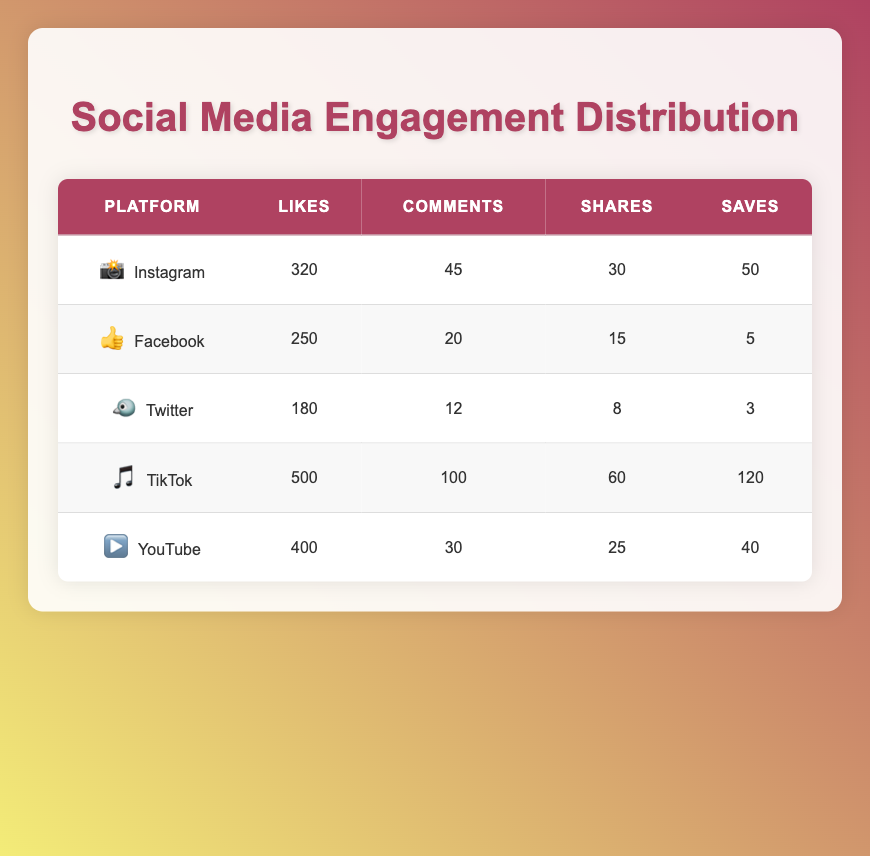What social media platform had the highest number of likes? By looking at the "Likes" column, TikTok has the highest value of 500 likes, which is greater than any other platform's like count.
Answer: TikTok Which platform had the least number of comments? The "Comments" column indicates that Twitter had the least comments, totaling 12, which is lower than any other platform's comments.
Answer: Twitter What is the total number of shares across all platforms? To find the total number of shares, we add the shares from each platform: (30 + 15 + 8 + 60 + 25) = 138 shares in total.
Answer: 138 How many more likes did Instagram receive compared to Facebook? We subtract Facebook's likes (250) from Instagram's likes (320): 320 - 250 = 70. Therefore, Instagram received 70 more likes than Facebook.
Answer: 70 Is it true that YouTube had more saves than Facebook? By comparing the "Saves" column, YouTube has 40 saves while Facebook only has 5 saves. Since 40 is greater than 5, the statement is true.
Answer: Yes What is the average number of comments across all platforms? To calculate the average, we first sum up all the comments: (45 + 20 + 12 + 100 + 30) = 207. There are 5 platforms, so the average is 207/5 = 41.4 comments.
Answer: 41.4 Which platform had the highest number of saves? The "Saves" column shows that TikTok has the highest number of saves, standing at 120, which is greater than all other platforms.
Answer: TikTok What is the median number of likes across these platforms? To find the median, we list the likes in ascending order: 180, 250, 320, 400, 500. The median lies in the middle of this ordered set, which is 320 for the third position.
Answer: 320 